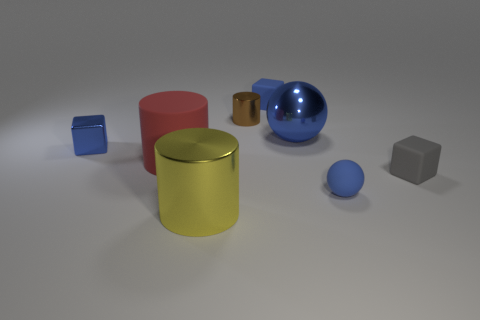There is a red matte object that is the same size as the yellow metallic object; what is its shape?
Keep it short and to the point. Cylinder. How many objects are blue things in front of the tiny gray matte cube or blue objects that are right of the large blue thing?
Offer a very short reply. 1. Are there fewer cyan matte things than rubber cylinders?
Make the answer very short. Yes. There is a cylinder that is the same size as the yellow shiny thing; what material is it?
Give a very brief answer. Rubber. There is a blue cube that is behind the brown cylinder; is its size the same as the blue thing that is to the left of the tiny cylinder?
Your answer should be compact. Yes. Are there any blue things made of the same material as the tiny ball?
Offer a terse response. Yes. What number of things are matte things that are behind the large red matte thing or small brown metallic cylinders?
Make the answer very short. 2. Do the small blue object to the left of the yellow metallic object and the big blue ball have the same material?
Make the answer very short. Yes. Is the shape of the small brown shiny object the same as the yellow thing?
Ensure brevity in your answer.  Yes. How many cylinders are in front of the small thing right of the rubber sphere?
Your response must be concise. 1. 